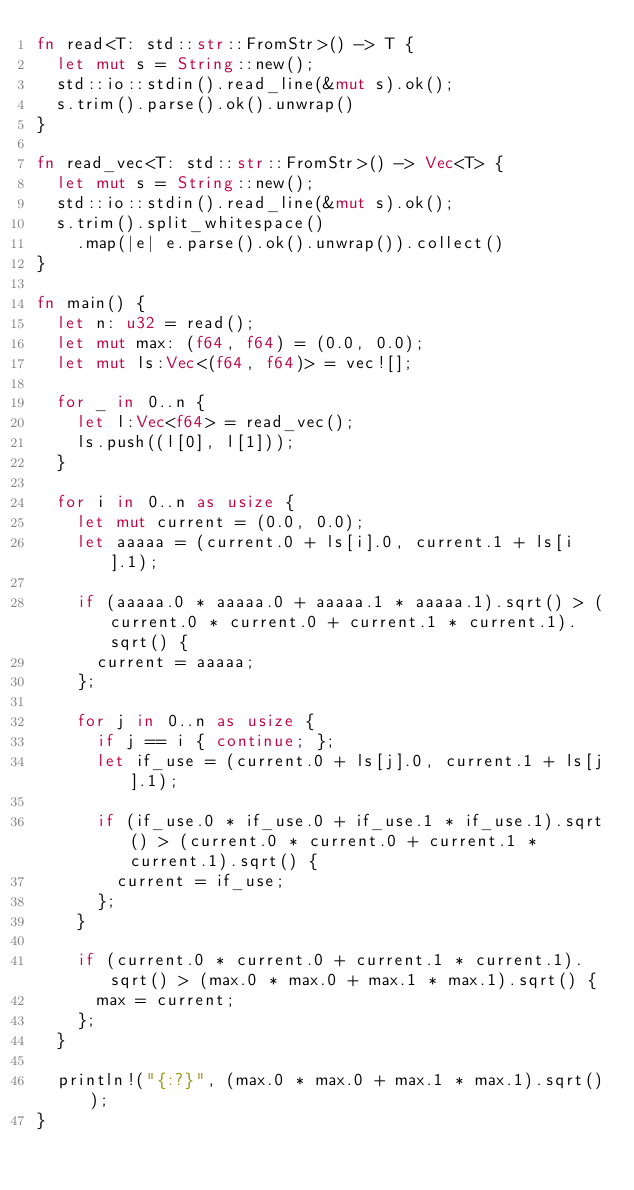<code> <loc_0><loc_0><loc_500><loc_500><_Rust_>fn read<T: std::str::FromStr>() -> T {
  let mut s = String::new();
  std::io::stdin().read_line(&mut s).ok();
  s.trim().parse().ok().unwrap()
}

fn read_vec<T: std::str::FromStr>() -> Vec<T> {
  let mut s = String::new();
  std::io::stdin().read_line(&mut s).ok();
  s.trim().split_whitespace()
    .map(|e| e.parse().ok().unwrap()).collect()
}

fn main() {
  let n: u32 = read();
  let mut max: (f64, f64) = (0.0, 0.0);
  let mut ls:Vec<(f64, f64)> = vec![];

  for _ in 0..n {
    let l:Vec<f64> = read_vec();
    ls.push((l[0], l[1]));
  }

  for i in 0..n as usize {
    let mut current = (0.0, 0.0);
    let aaaaa = (current.0 + ls[i].0, current.1 + ls[i].1);

    if (aaaaa.0 * aaaaa.0 + aaaaa.1 * aaaaa.1).sqrt() > (current.0 * current.0 + current.1 * current.1).sqrt() {
      current = aaaaa;
    };

    for j in 0..n as usize {
      if j == i { continue; };
      let if_use = (current.0 + ls[j].0, current.1 + ls[j].1);

      if (if_use.0 * if_use.0 + if_use.1 * if_use.1).sqrt() > (current.0 * current.0 + current.1 * current.1).sqrt() {
        current = if_use;
      };
    }

    if (current.0 * current.0 + current.1 * current.1).sqrt() > (max.0 * max.0 + max.1 * max.1).sqrt() {
      max = current;
    };
  }

  println!("{:?}", (max.0 * max.0 + max.1 * max.1).sqrt());
}
</code> 